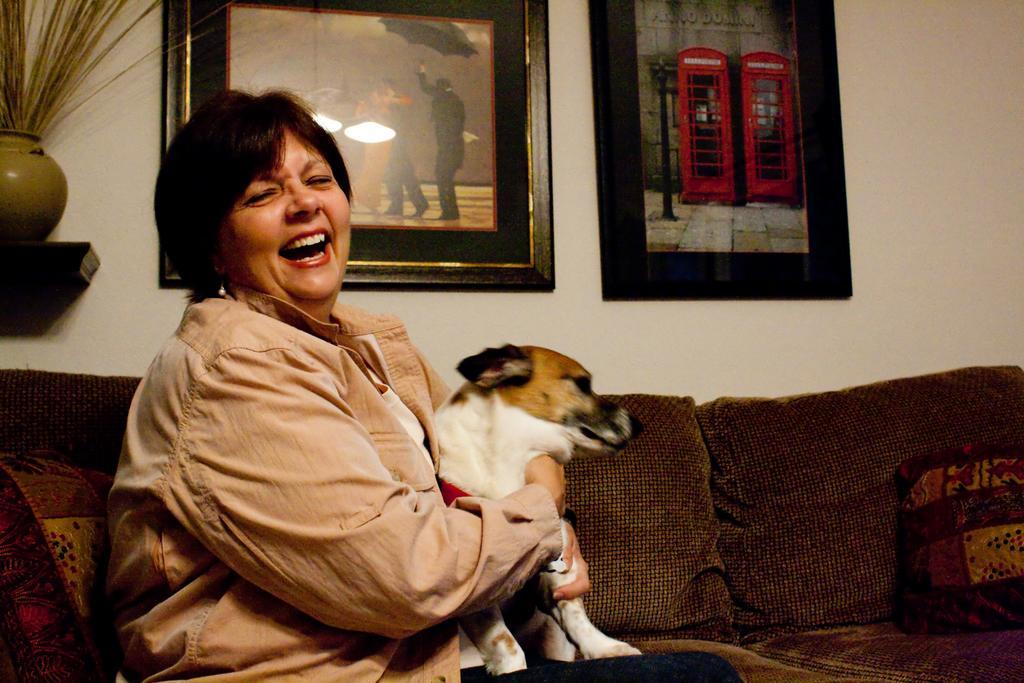Could you give a brief overview of what you see in this image? A woman is sitting in a sofa with her hands spread around a dog sitting beside her. 